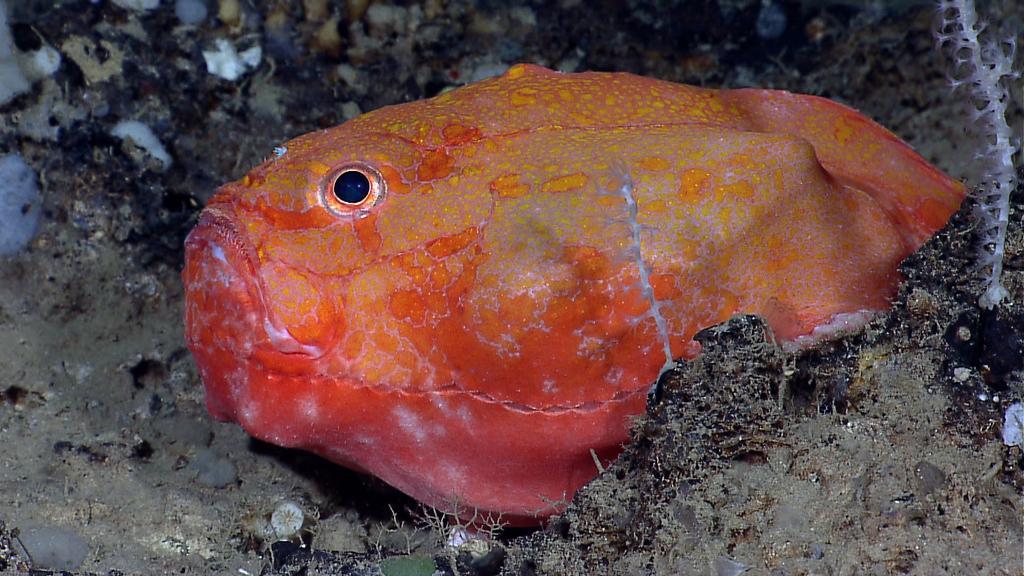Please provide a concise description of this image. In this image I can see a fish which is in orange and yellow color. I can see a grey and black color surface. 